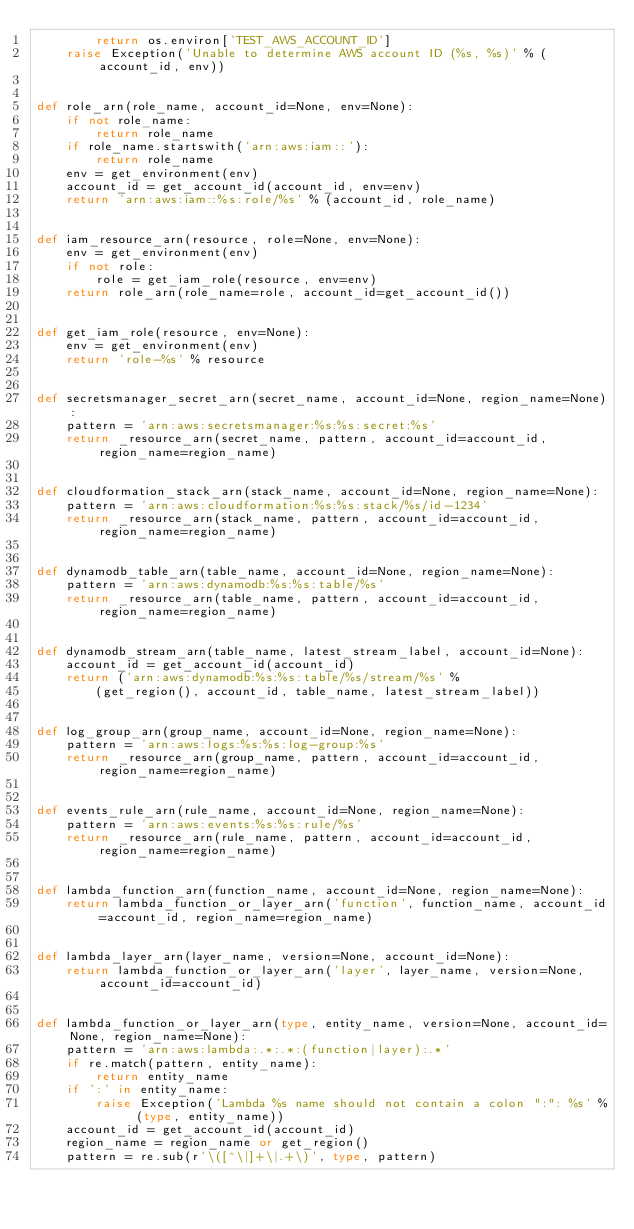<code> <loc_0><loc_0><loc_500><loc_500><_Python_>        return os.environ['TEST_AWS_ACCOUNT_ID']
    raise Exception('Unable to determine AWS account ID (%s, %s)' % (account_id, env))


def role_arn(role_name, account_id=None, env=None):
    if not role_name:
        return role_name
    if role_name.startswith('arn:aws:iam::'):
        return role_name
    env = get_environment(env)
    account_id = get_account_id(account_id, env=env)
    return 'arn:aws:iam::%s:role/%s' % (account_id, role_name)


def iam_resource_arn(resource, role=None, env=None):
    env = get_environment(env)
    if not role:
        role = get_iam_role(resource, env=env)
    return role_arn(role_name=role, account_id=get_account_id())


def get_iam_role(resource, env=None):
    env = get_environment(env)
    return 'role-%s' % resource


def secretsmanager_secret_arn(secret_name, account_id=None, region_name=None):
    pattern = 'arn:aws:secretsmanager:%s:%s:secret:%s'
    return _resource_arn(secret_name, pattern, account_id=account_id, region_name=region_name)


def cloudformation_stack_arn(stack_name, account_id=None, region_name=None):
    pattern = 'arn:aws:cloudformation:%s:%s:stack/%s/id-1234'
    return _resource_arn(stack_name, pattern, account_id=account_id, region_name=region_name)


def dynamodb_table_arn(table_name, account_id=None, region_name=None):
    pattern = 'arn:aws:dynamodb:%s:%s:table/%s'
    return _resource_arn(table_name, pattern, account_id=account_id, region_name=region_name)


def dynamodb_stream_arn(table_name, latest_stream_label, account_id=None):
    account_id = get_account_id(account_id)
    return ('arn:aws:dynamodb:%s:%s:table/%s/stream/%s' %
        (get_region(), account_id, table_name, latest_stream_label))


def log_group_arn(group_name, account_id=None, region_name=None):
    pattern = 'arn:aws:logs:%s:%s:log-group:%s'
    return _resource_arn(group_name, pattern, account_id=account_id, region_name=region_name)


def events_rule_arn(rule_name, account_id=None, region_name=None):
    pattern = 'arn:aws:events:%s:%s:rule/%s'
    return _resource_arn(rule_name, pattern, account_id=account_id, region_name=region_name)


def lambda_function_arn(function_name, account_id=None, region_name=None):
    return lambda_function_or_layer_arn('function', function_name, account_id=account_id, region_name=region_name)


def lambda_layer_arn(layer_name, version=None, account_id=None):
    return lambda_function_or_layer_arn('layer', layer_name, version=None, account_id=account_id)


def lambda_function_or_layer_arn(type, entity_name, version=None, account_id=None, region_name=None):
    pattern = 'arn:aws:lambda:.*:.*:(function|layer):.*'
    if re.match(pattern, entity_name):
        return entity_name
    if ':' in entity_name:
        raise Exception('Lambda %s name should not contain a colon ":": %s' % (type, entity_name))
    account_id = get_account_id(account_id)
    region_name = region_name or get_region()
    pattern = re.sub(r'\([^\|]+\|.+\)', type, pattern)</code> 